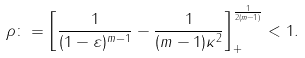<formula> <loc_0><loc_0><loc_500><loc_500>\rho \colon = \left [ \frac { 1 } { ( 1 - \varepsilon ) ^ { m - 1 } } - \frac { 1 } { ( m - 1 ) \kappa ^ { 2 } } \right ] _ { + } ^ { \frac { 1 } { 2 ( m - 1 ) } } < 1 .</formula> 